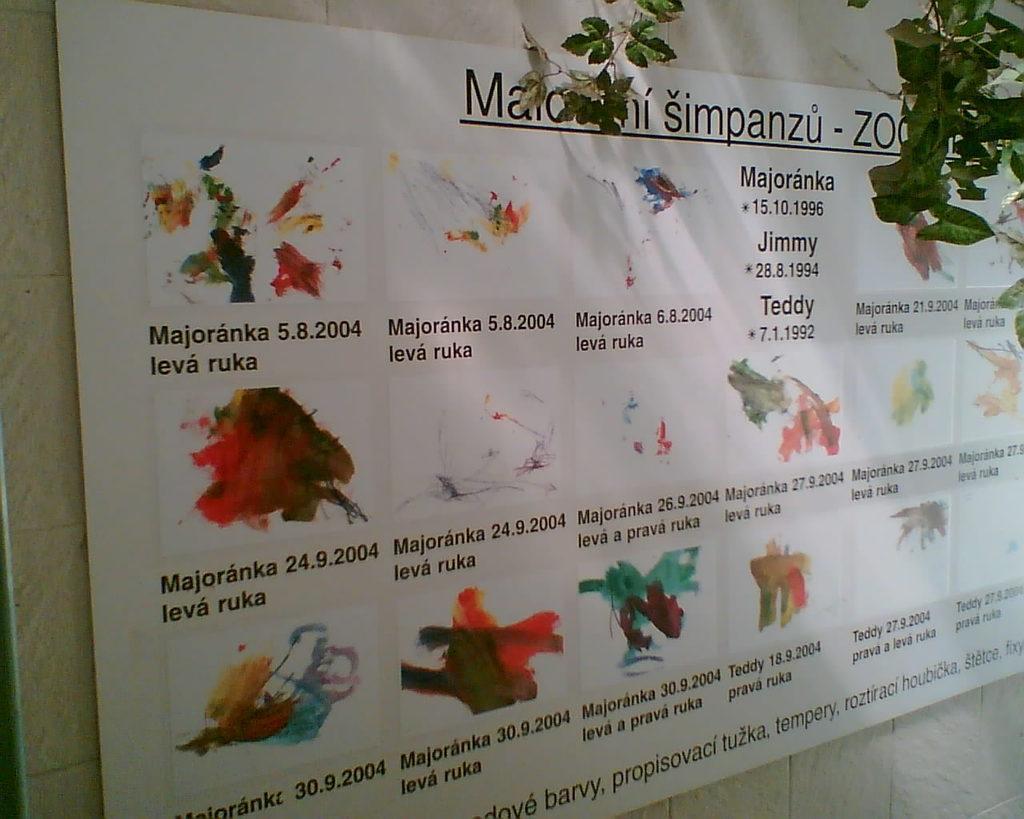How would you summarize this image in a sentence or two? In this image, we can see a banner on the wall. There are branches in the top right of the image. 